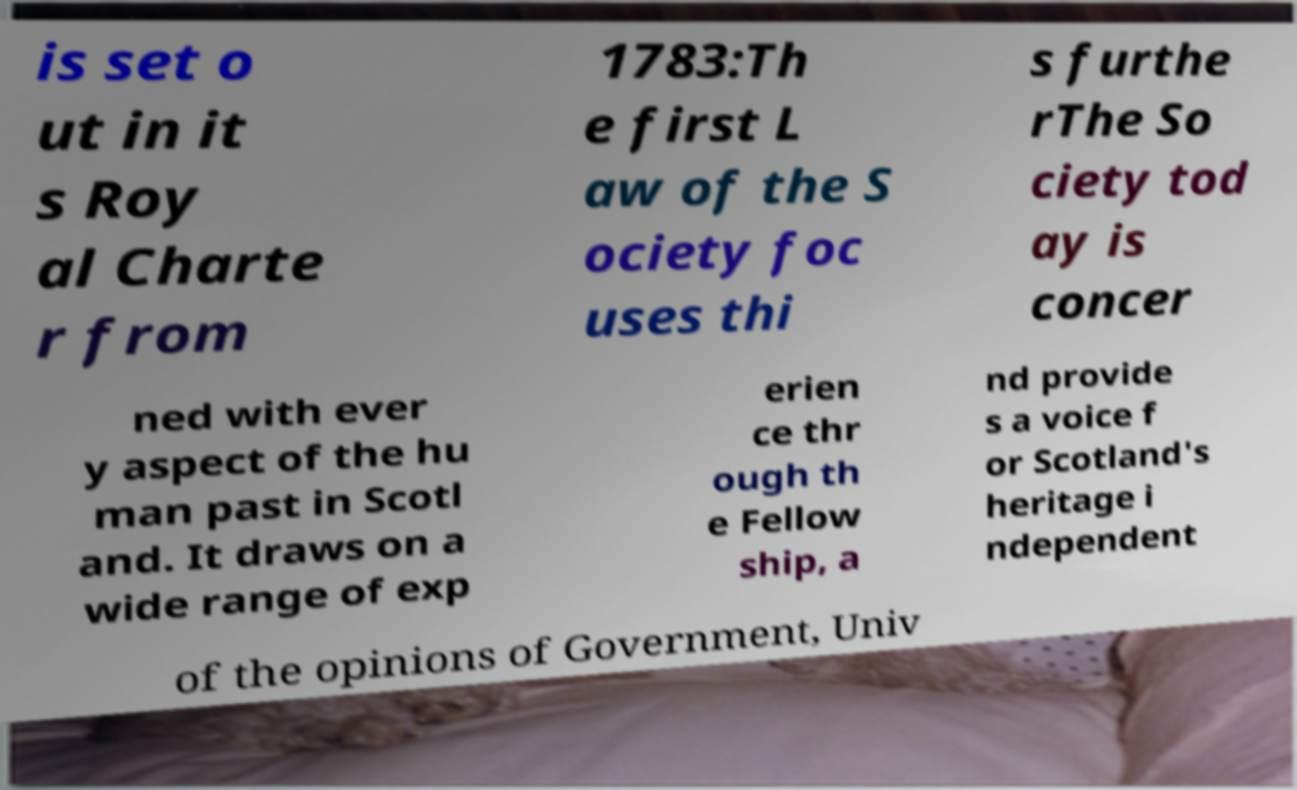Can you accurately transcribe the text from the provided image for me? is set o ut in it s Roy al Charte r from 1783:Th e first L aw of the S ociety foc uses thi s furthe rThe So ciety tod ay is concer ned with ever y aspect of the hu man past in Scotl and. It draws on a wide range of exp erien ce thr ough th e Fellow ship, a nd provide s a voice f or Scotland's heritage i ndependent of the opinions of Government, Univ 